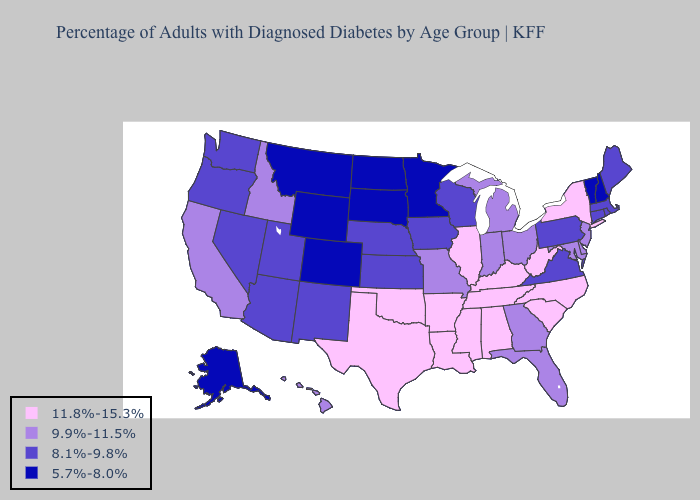Among the states that border Idaho , which have the highest value?
Keep it brief. Nevada, Oregon, Utah, Washington. Does Missouri have the same value as Indiana?
Answer briefly. Yes. What is the value of Washington?
Keep it brief. 8.1%-9.8%. Does New York have the highest value in the USA?
Give a very brief answer. Yes. What is the lowest value in the USA?
Answer briefly. 5.7%-8.0%. Does New Mexico have the lowest value in the West?
Concise answer only. No. What is the value of Alaska?
Give a very brief answer. 5.7%-8.0%. Name the states that have a value in the range 9.9%-11.5%?
Keep it brief. California, Delaware, Florida, Georgia, Hawaii, Idaho, Indiana, Maryland, Michigan, Missouri, New Jersey, Ohio. Does South Carolina have the same value as Idaho?
Write a very short answer. No. What is the lowest value in the USA?
Be succinct. 5.7%-8.0%. Name the states that have a value in the range 11.8%-15.3%?
Quick response, please. Alabama, Arkansas, Illinois, Kentucky, Louisiana, Mississippi, New York, North Carolina, Oklahoma, South Carolina, Tennessee, Texas, West Virginia. What is the highest value in states that border Nebraska?
Be succinct. 9.9%-11.5%. What is the value of New Jersey?
Short answer required. 9.9%-11.5%. What is the highest value in states that border Nebraska?
Write a very short answer. 9.9%-11.5%. Does the map have missing data?
Quick response, please. No. 